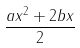<formula> <loc_0><loc_0><loc_500><loc_500>\frac { a x ^ { 2 } + 2 b x } { 2 }</formula> 